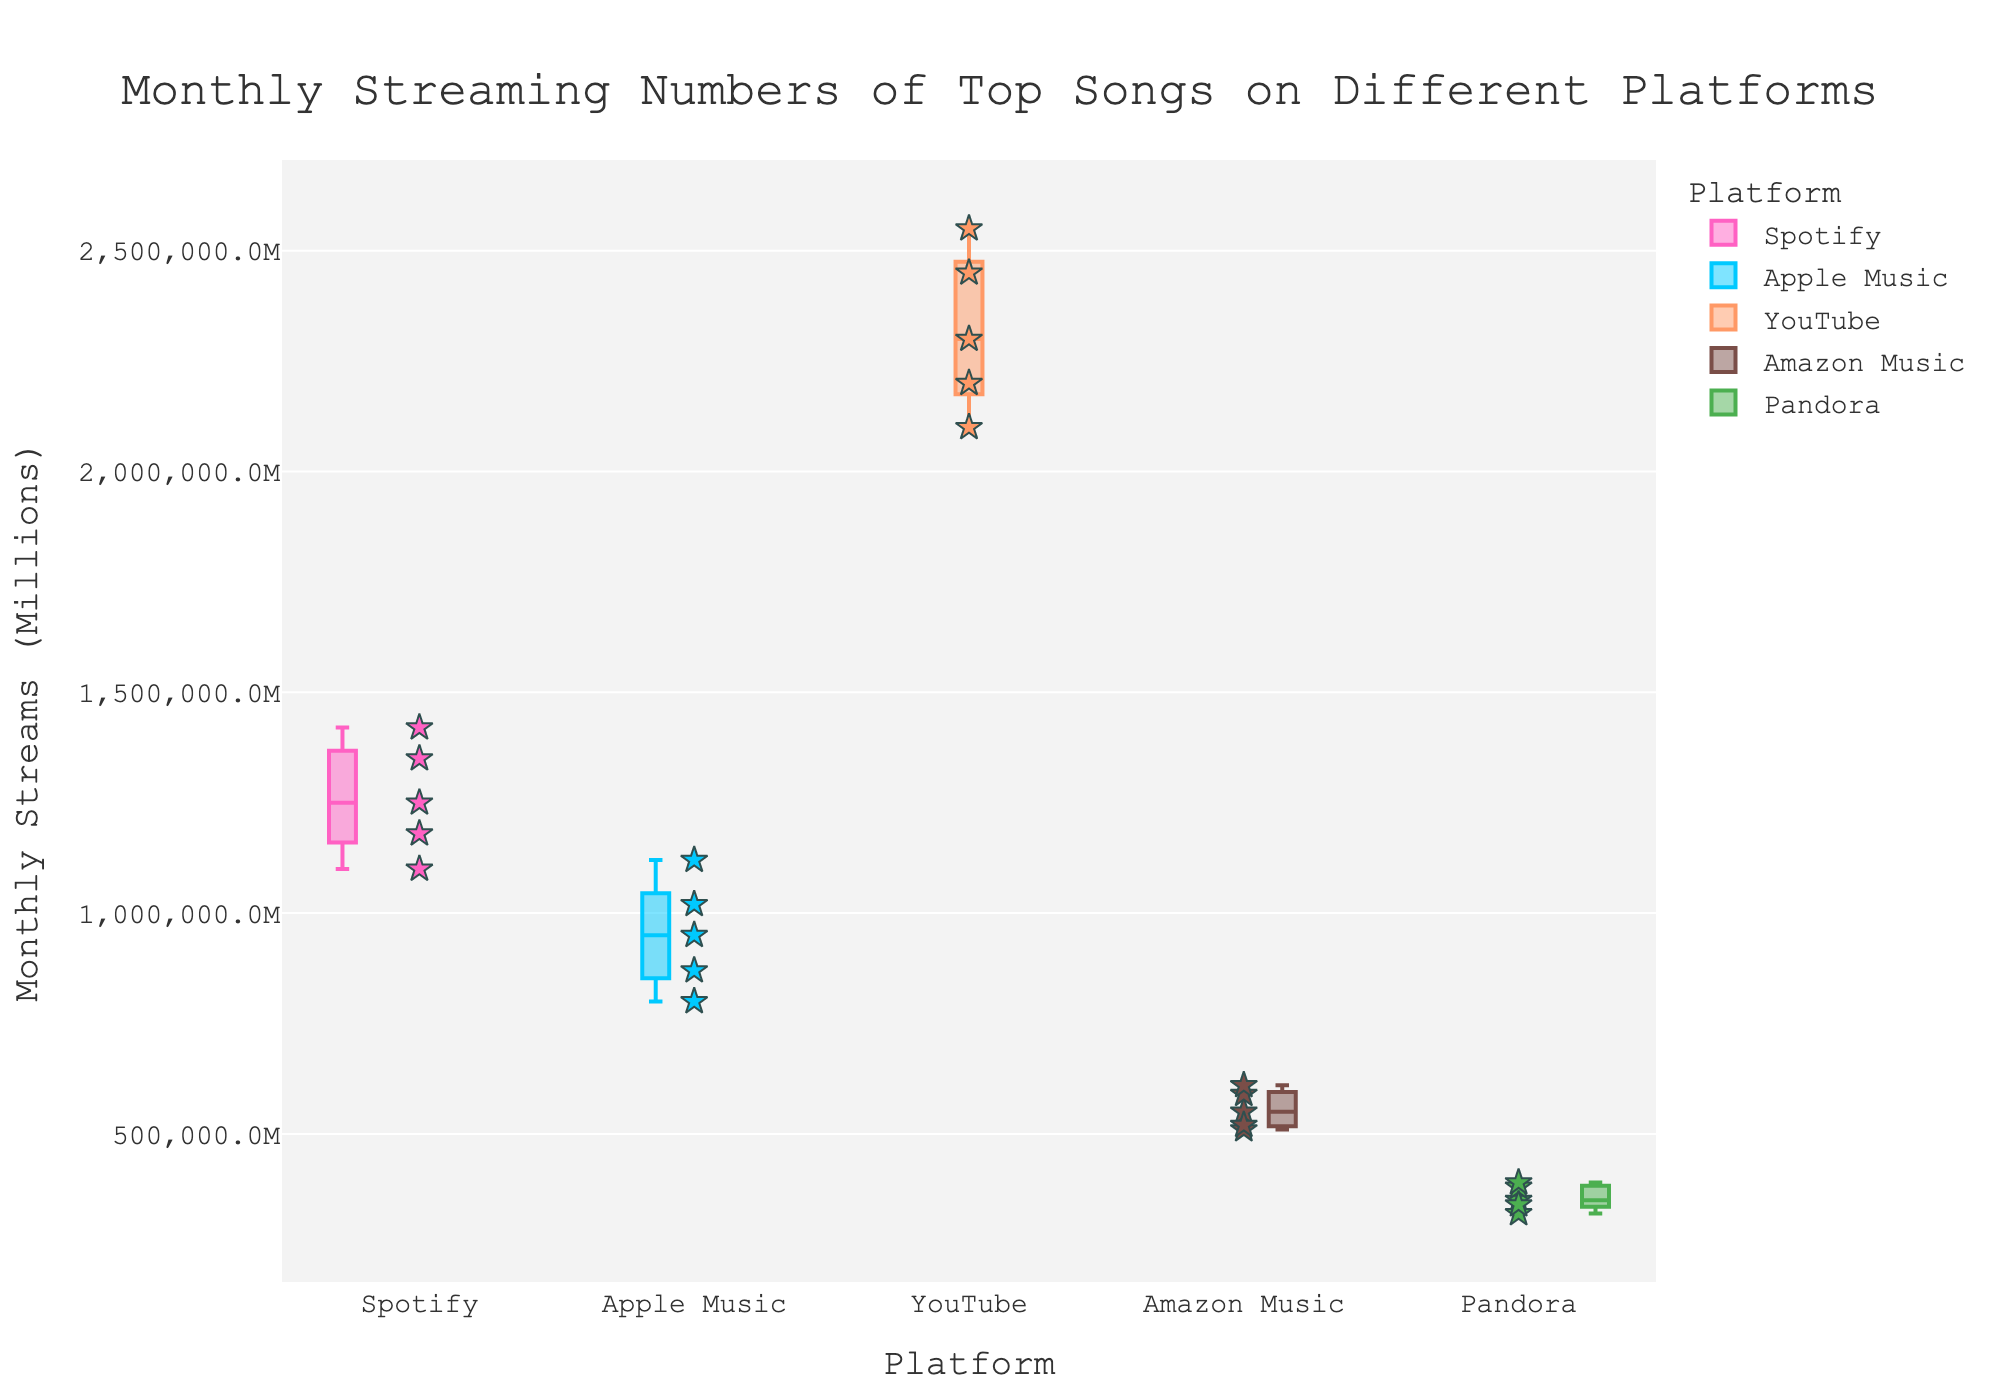What is the title of the chart? The title is displayed at the top of the figure. It reads "Monthly Streaming Numbers of Top Songs on Different Platforms".
Answer: Monthly Streaming Numbers of Top Songs on Different Platforms Which platform has the highest range in monthly streams? From the box plots, YouTube has the widest range of monthly streams, indicated by the larger spread of the box and whiskers.
Answer: YouTube What is the median monthly streams value for Spotify? The median value is indicated by the line inside the box for Spotify. By checking this line, Spotify’s median is slightly above 1,200,000 streams.
Answer: Around 1,200,000 Which song has the highest monthly streams on all platforms? The scatter points or stars outside the boxes can show individual song data. "Cosmic Waves" on YouTube has the highest streams, shown by the highest point.
Answer: Cosmic Waves on YouTube What is the interquartile range (IQR) for Apple Music? IQR is the difference between the upper quartile (Q3) and the lower quartile (Q1). For Apple Music, Q3 is around 1,020,000 and Q1 is near 870,000. Thus, the IQR is 1,020,000 - 870,000 = 150,000.
Answer: 150,000 Which platform has the lowest average monthly streams? By observing the central tendency of box plots, Pandora has the lowest average monthly streams among all platforms, indicated by its overall lower placement.
Answer: Pandora Compare the median monthly streams between YouTube and Amazon Music. Which is higher? The median is indicated by the line inside each box. YouTube’s median is significantly higher than Amazon Music’s median.
Answer: YouTube What is the overall trend in the median monthly streams across different platforms? By observing the medians (lines inside the boxes), there is an upward trend from lower to higher monthly streams, starting with Pandora and ending with YouTube.
Answer: Increasing from Pandora to YouTube Which platform has the shortest whiskers, indicating lower variability in streams? By examining the length of the whiskers (lines extending from the box), Amazon Music has the shortest whiskers, indicating lower variability.
Answer: Amazon Music 